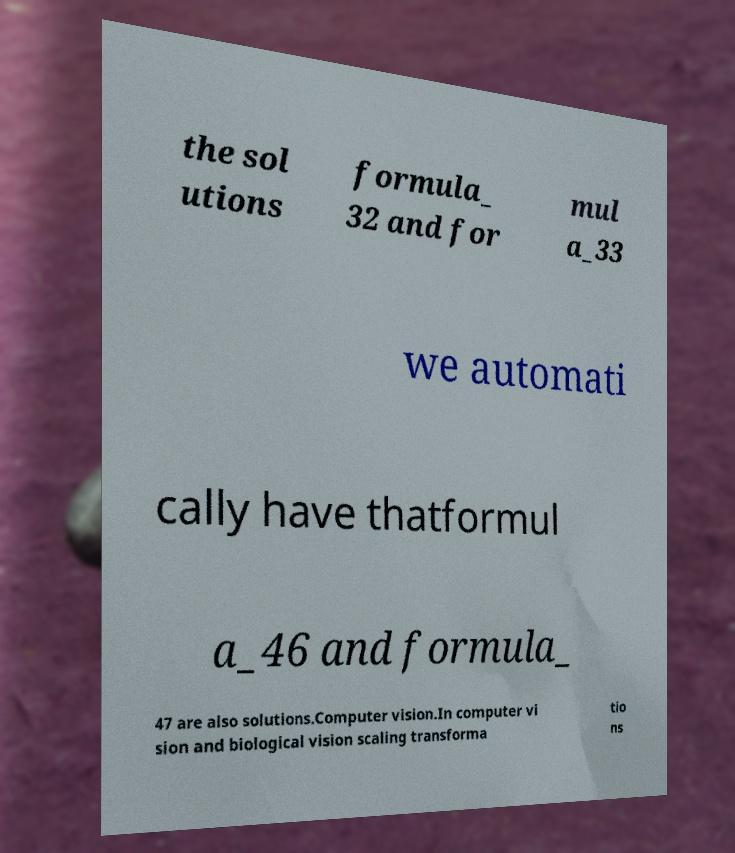Can you read and provide the text displayed in the image?This photo seems to have some interesting text. Can you extract and type it out for me? the sol utions formula_ 32 and for mul a_33 we automati cally have thatformul a_46 and formula_ 47 are also solutions.Computer vision.In computer vi sion and biological vision scaling transforma tio ns 